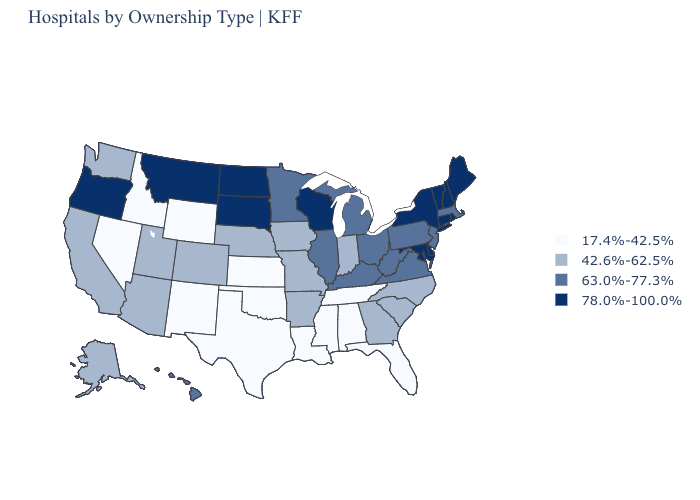Which states hav the highest value in the West?
Be succinct. Montana, Oregon. What is the lowest value in states that border West Virginia?
Keep it brief. 63.0%-77.3%. Among the states that border Missouri , does Kansas have the lowest value?
Concise answer only. Yes. Name the states that have a value in the range 17.4%-42.5%?
Write a very short answer. Alabama, Florida, Idaho, Kansas, Louisiana, Mississippi, Nevada, New Mexico, Oklahoma, Tennessee, Texas, Wyoming. What is the highest value in states that border Ohio?
Give a very brief answer. 63.0%-77.3%. Name the states that have a value in the range 42.6%-62.5%?
Quick response, please. Alaska, Arizona, Arkansas, California, Colorado, Georgia, Indiana, Iowa, Missouri, Nebraska, North Carolina, South Carolina, Utah, Washington. Does Michigan have a lower value than North Dakota?
Short answer required. Yes. What is the lowest value in the Northeast?
Keep it brief. 63.0%-77.3%. How many symbols are there in the legend?
Be succinct. 4. What is the lowest value in the USA?
Concise answer only. 17.4%-42.5%. Does the first symbol in the legend represent the smallest category?
Keep it brief. Yes. What is the highest value in the MidWest ?
Give a very brief answer. 78.0%-100.0%. What is the lowest value in the USA?
Quick response, please. 17.4%-42.5%. What is the value of Connecticut?
Short answer required. 78.0%-100.0%. What is the value of New York?
Give a very brief answer. 78.0%-100.0%. 